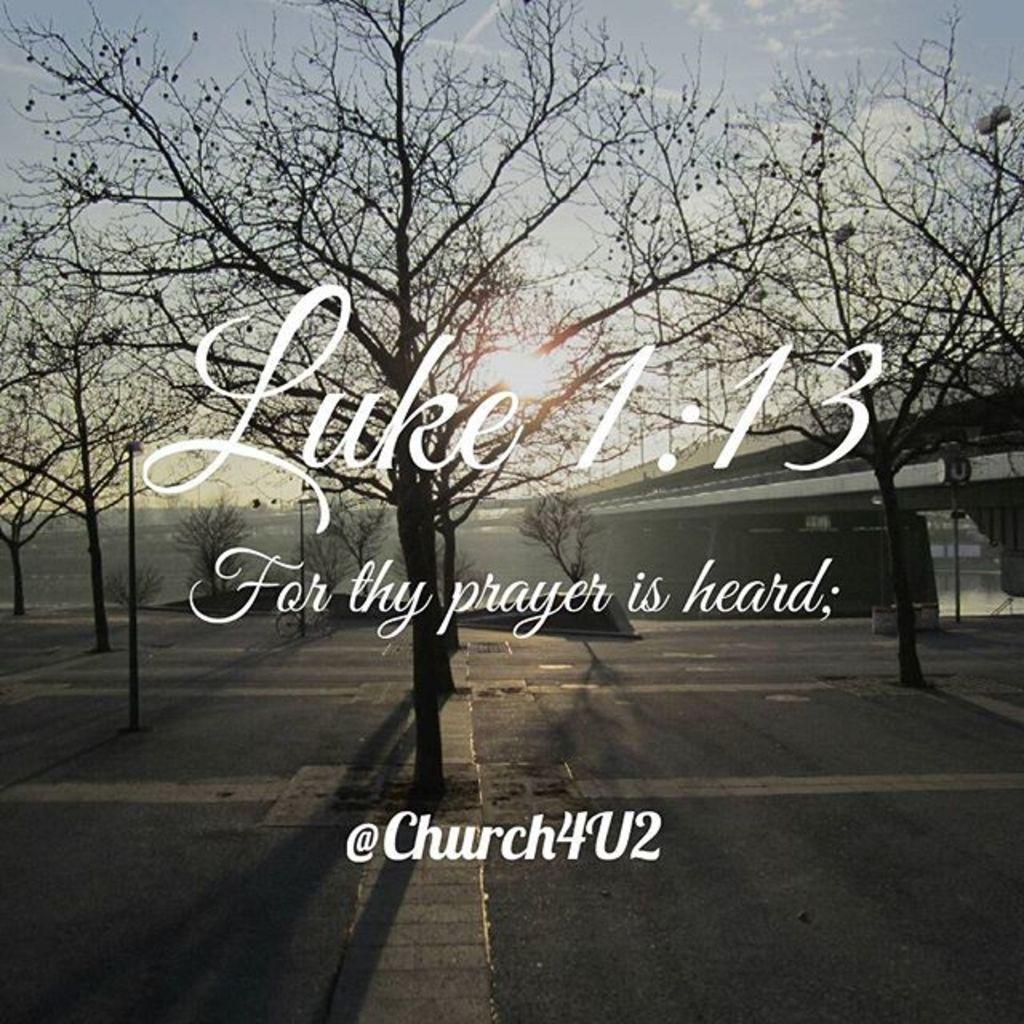Describe this image in one or two sentences. At the bottom of the image there is a road with many trees without leaves and also there are few poles. In the background there is a flyover. At the top of the image there is a sky. 